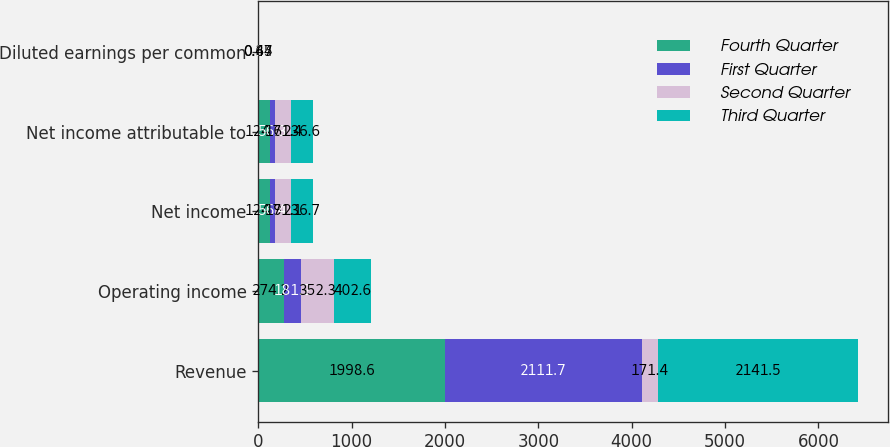Convert chart. <chart><loc_0><loc_0><loc_500><loc_500><stacked_bar_chart><ecel><fcel>Revenue<fcel>Operating income<fcel>Net income<fcel>Net income attributable to<fcel>Diluted earnings per common<nl><fcel>Fourth Quarter<fcel>1998.6<fcel>274.2<fcel>124.9<fcel>124.6<fcel>0.34<nl><fcel>First Quarter<fcel>2111.7<fcel>181.2<fcel>56.4<fcel>56.3<fcel>0.15<nl><fcel>Second Quarter<fcel>171.4<fcel>352.3<fcel>171.1<fcel>171.4<fcel>0.47<nl><fcel>Third Quarter<fcel>2141.5<fcel>402.6<fcel>236.7<fcel>236.6<fcel>0.65<nl></chart> 